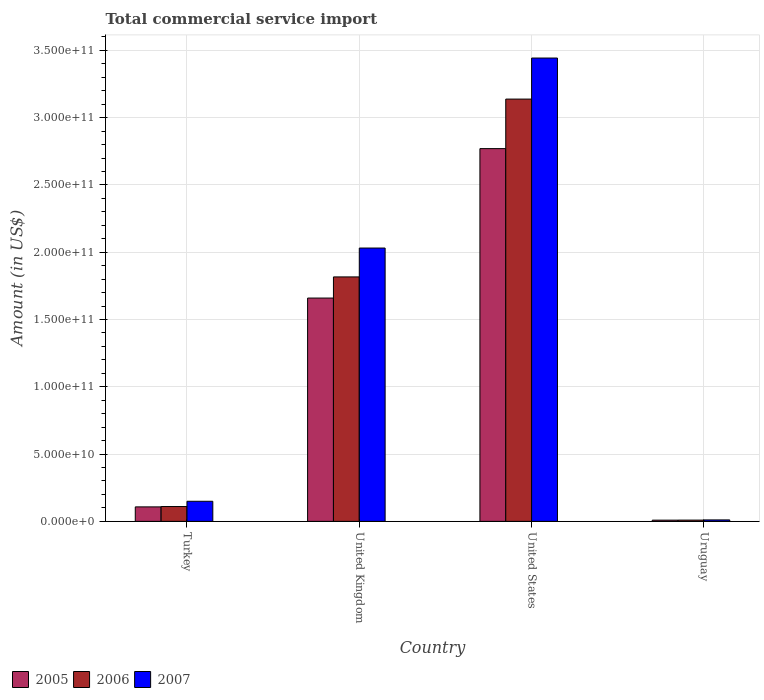How many bars are there on the 1st tick from the left?
Make the answer very short. 3. How many bars are there on the 3rd tick from the right?
Your answer should be compact. 3. What is the total commercial service import in 2006 in United States?
Give a very brief answer. 3.14e+11. Across all countries, what is the maximum total commercial service import in 2006?
Provide a short and direct response. 3.14e+11. Across all countries, what is the minimum total commercial service import in 2006?
Your answer should be compact. 9.37e+08. In which country was the total commercial service import in 2005 minimum?
Offer a terse response. Uruguay. What is the total total commercial service import in 2006 in the graph?
Your answer should be very brief. 5.07e+11. What is the difference between the total commercial service import in 2006 in United States and that in Uruguay?
Your response must be concise. 3.13e+11. What is the difference between the total commercial service import in 2006 in Turkey and the total commercial service import in 2007 in Uruguay?
Give a very brief answer. 9.94e+09. What is the average total commercial service import in 2005 per country?
Ensure brevity in your answer.  1.14e+11. What is the difference between the total commercial service import of/in 2006 and total commercial service import of/in 2005 in United Kingdom?
Keep it short and to the point. 1.57e+1. In how many countries, is the total commercial service import in 2005 greater than 30000000000 US$?
Give a very brief answer. 2. What is the ratio of the total commercial service import in 2006 in United Kingdom to that in United States?
Your response must be concise. 0.58. Is the total commercial service import in 2005 in United Kingdom less than that in United States?
Ensure brevity in your answer.  Yes. Is the difference between the total commercial service import in 2006 in Turkey and United States greater than the difference between the total commercial service import in 2005 in Turkey and United States?
Offer a terse response. No. What is the difference between the highest and the second highest total commercial service import in 2005?
Ensure brevity in your answer.  2.66e+11. What is the difference between the highest and the lowest total commercial service import in 2005?
Offer a very short reply. 2.76e+11. In how many countries, is the total commercial service import in 2007 greater than the average total commercial service import in 2007 taken over all countries?
Provide a short and direct response. 2. What does the 3rd bar from the left in United Kingdom represents?
Provide a succinct answer. 2007. Is it the case that in every country, the sum of the total commercial service import in 2005 and total commercial service import in 2007 is greater than the total commercial service import in 2006?
Your answer should be compact. Yes. How many bars are there?
Offer a terse response. 12. How many countries are there in the graph?
Provide a succinct answer. 4. What is the difference between two consecutive major ticks on the Y-axis?
Your answer should be very brief. 5.00e+1. Are the values on the major ticks of Y-axis written in scientific E-notation?
Your answer should be very brief. Yes. Does the graph contain any zero values?
Your answer should be very brief. No. Does the graph contain grids?
Offer a terse response. Yes. How many legend labels are there?
Keep it short and to the point. 3. What is the title of the graph?
Your response must be concise. Total commercial service import. What is the label or title of the Y-axis?
Ensure brevity in your answer.  Amount (in US$). What is the Amount (in US$) of 2005 in Turkey?
Provide a short and direct response. 1.08e+1. What is the Amount (in US$) in 2006 in Turkey?
Ensure brevity in your answer.  1.10e+1. What is the Amount (in US$) of 2007 in Turkey?
Make the answer very short. 1.49e+1. What is the Amount (in US$) of 2005 in United Kingdom?
Your response must be concise. 1.66e+11. What is the Amount (in US$) of 2006 in United Kingdom?
Provide a succinct answer. 1.82e+11. What is the Amount (in US$) in 2007 in United Kingdom?
Your answer should be compact. 2.03e+11. What is the Amount (in US$) of 2005 in United States?
Give a very brief answer. 2.77e+11. What is the Amount (in US$) of 2006 in United States?
Your response must be concise. 3.14e+11. What is the Amount (in US$) in 2007 in United States?
Your answer should be compact. 3.44e+11. What is the Amount (in US$) in 2005 in Uruguay?
Offer a terse response. 9.01e+08. What is the Amount (in US$) of 2006 in Uruguay?
Ensure brevity in your answer.  9.37e+08. What is the Amount (in US$) in 2007 in Uruguay?
Your answer should be very brief. 1.08e+09. Across all countries, what is the maximum Amount (in US$) in 2005?
Provide a succinct answer. 2.77e+11. Across all countries, what is the maximum Amount (in US$) in 2006?
Offer a terse response. 3.14e+11. Across all countries, what is the maximum Amount (in US$) of 2007?
Keep it short and to the point. 3.44e+11. Across all countries, what is the minimum Amount (in US$) of 2005?
Provide a short and direct response. 9.01e+08. Across all countries, what is the minimum Amount (in US$) of 2006?
Offer a terse response. 9.37e+08. Across all countries, what is the minimum Amount (in US$) of 2007?
Keep it short and to the point. 1.08e+09. What is the total Amount (in US$) in 2005 in the graph?
Give a very brief answer. 4.55e+11. What is the total Amount (in US$) of 2006 in the graph?
Provide a short and direct response. 5.07e+11. What is the total Amount (in US$) of 2007 in the graph?
Provide a succinct answer. 5.63e+11. What is the difference between the Amount (in US$) of 2005 in Turkey and that in United Kingdom?
Ensure brevity in your answer.  -1.55e+11. What is the difference between the Amount (in US$) in 2006 in Turkey and that in United Kingdom?
Offer a terse response. -1.71e+11. What is the difference between the Amount (in US$) of 2007 in Turkey and that in United Kingdom?
Provide a succinct answer. -1.88e+11. What is the difference between the Amount (in US$) of 2005 in Turkey and that in United States?
Make the answer very short. -2.66e+11. What is the difference between the Amount (in US$) of 2006 in Turkey and that in United States?
Provide a short and direct response. -3.03e+11. What is the difference between the Amount (in US$) in 2007 in Turkey and that in United States?
Provide a succinct answer. -3.29e+11. What is the difference between the Amount (in US$) of 2005 in Turkey and that in Uruguay?
Give a very brief answer. 9.86e+09. What is the difference between the Amount (in US$) in 2006 in Turkey and that in Uruguay?
Your answer should be very brief. 1.01e+1. What is the difference between the Amount (in US$) of 2007 in Turkey and that in Uruguay?
Your answer should be compact. 1.39e+1. What is the difference between the Amount (in US$) in 2005 in United Kingdom and that in United States?
Your response must be concise. -1.11e+11. What is the difference between the Amount (in US$) in 2006 in United Kingdom and that in United States?
Give a very brief answer. -1.32e+11. What is the difference between the Amount (in US$) of 2007 in United Kingdom and that in United States?
Your response must be concise. -1.41e+11. What is the difference between the Amount (in US$) in 2005 in United Kingdom and that in Uruguay?
Give a very brief answer. 1.65e+11. What is the difference between the Amount (in US$) of 2006 in United Kingdom and that in Uruguay?
Provide a succinct answer. 1.81e+11. What is the difference between the Amount (in US$) of 2007 in United Kingdom and that in Uruguay?
Provide a succinct answer. 2.02e+11. What is the difference between the Amount (in US$) in 2005 in United States and that in Uruguay?
Your answer should be very brief. 2.76e+11. What is the difference between the Amount (in US$) of 2006 in United States and that in Uruguay?
Offer a terse response. 3.13e+11. What is the difference between the Amount (in US$) of 2007 in United States and that in Uruguay?
Ensure brevity in your answer.  3.43e+11. What is the difference between the Amount (in US$) of 2005 in Turkey and the Amount (in US$) of 2006 in United Kingdom?
Offer a very short reply. -1.71e+11. What is the difference between the Amount (in US$) in 2005 in Turkey and the Amount (in US$) in 2007 in United Kingdom?
Offer a very short reply. -1.92e+11. What is the difference between the Amount (in US$) in 2006 in Turkey and the Amount (in US$) in 2007 in United Kingdom?
Offer a very short reply. -1.92e+11. What is the difference between the Amount (in US$) of 2005 in Turkey and the Amount (in US$) of 2006 in United States?
Your answer should be compact. -3.03e+11. What is the difference between the Amount (in US$) in 2005 in Turkey and the Amount (in US$) in 2007 in United States?
Keep it short and to the point. -3.34e+11. What is the difference between the Amount (in US$) in 2006 in Turkey and the Amount (in US$) in 2007 in United States?
Your answer should be very brief. -3.33e+11. What is the difference between the Amount (in US$) of 2005 in Turkey and the Amount (in US$) of 2006 in Uruguay?
Provide a short and direct response. 9.82e+09. What is the difference between the Amount (in US$) in 2005 in Turkey and the Amount (in US$) in 2007 in Uruguay?
Ensure brevity in your answer.  9.68e+09. What is the difference between the Amount (in US$) of 2006 in Turkey and the Amount (in US$) of 2007 in Uruguay?
Your answer should be compact. 9.94e+09. What is the difference between the Amount (in US$) in 2005 in United Kingdom and the Amount (in US$) in 2006 in United States?
Keep it short and to the point. -1.48e+11. What is the difference between the Amount (in US$) of 2005 in United Kingdom and the Amount (in US$) of 2007 in United States?
Provide a succinct answer. -1.78e+11. What is the difference between the Amount (in US$) in 2006 in United Kingdom and the Amount (in US$) in 2007 in United States?
Provide a short and direct response. -1.63e+11. What is the difference between the Amount (in US$) in 2005 in United Kingdom and the Amount (in US$) in 2006 in Uruguay?
Offer a terse response. 1.65e+11. What is the difference between the Amount (in US$) in 2005 in United Kingdom and the Amount (in US$) in 2007 in Uruguay?
Provide a succinct answer. 1.65e+11. What is the difference between the Amount (in US$) of 2006 in United Kingdom and the Amount (in US$) of 2007 in Uruguay?
Give a very brief answer. 1.81e+11. What is the difference between the Amount (in US$) in 2005 in United States and the Amount (in US$) in 2006 in Uruguay?
Your answer should be very brief. 2.76e+11. What is the difference between the Amount (in US$) of 2005 in United States and the Amount (in US$) of 2007 in Uruguay?
Give a very brief answer. 2.76e+11. What is the difference between the Amount (in US$) in 2006 in United States and the Amount (in US$) in 2007 in Uruguay?
Ensure brevity in your answer.  3.13e+11. What is the average Amount (in US$) in 2005 per country?
Your answer should be compact. 1.14e+11. What is the average Amount (in US$) in 2006 per country?
Your response must be concise. 1.27e+11. What is the average Amount (in US$) in 2007 per country?
Offer a terse response. 1.41e+11. What is the difference between the Amount (in US$) of 2005 and Amount (in US$) of 2006 in Turkey?
Make the answer very short. -2.61e+08. What is the difference between the Amount (in US$) in 2005 and Amount (in US$) in 2007 in Turkey?
Make the answer very short. -4.18e+09. What is the difference between the Amount (in US$) in 2006 and Amount (in US$) in 2007 in Turkey?
Give a very brief answer. -3.92e+09. What is the difference between the Amount (in US$) of 2005 and Amount (in US$) of 2006 in United Kingdom?
Offer a very short reply. -1.57e+1. What is the difference between the Amount (in US$) of 2005 and Amount (in US$) of 2007 in United Kingdom?
Your answer should be compact. -3.72e+1. What is the difference between the Amount (in US$) in 2006 and Amount (in US$) in 2007 in United Kingdom?
Give a very brief answer. -2.15e+1. What is the difference between the Amount (in US$) in 2005 and Amount (in US$) in 2006 in United States?
Provide a succinct answer. -3.68e+1. What is the difference between the Amount (in US$) in 2005 and Amount (in US$) in 2007 in United States?
Offer a very short reply. -6.73e+1. What is the difference between the Amount (in US$) of 2006 and Amount (in US$) of 2007 in United States?
Your answer should be very brief. -3.05e+1. What is the difference between the Amount (in US$) in 2005 and Amount (in US$) in 2006 in Uruguay?
Provide a succinct answer. -3.66e+07. What is the difference between the Amount (in US$) in 2005 and Amount (in US$) in 2007 in Uruguay?
Your answer should be very brief. -1.78e+08. What is the difference between the Amount (in US$) of 2006 and Amount (in US$) of 2007 in Uruguay?
Your response must be concise. -1.41e+08. What is the ratio of the Amount (in US$) in 2005 in Turkey to that in United Kingdom?
Your answer should be very brief. 0.06. What is the ratio of the Amount (in US$) of 2006 in Turkey to that in United Kingdom?
Offer a terse response. 0.06. What is the ratio of the Amount (in US$) of 2007 in Turkey to that in United Kingdom?
Keep it short and to the point. 0.07. What is the ratio of the Amount (in US$) in 2005 in Turkey to that in United States?
Give a very brief answer. 0.04. What is the ratio of the Amount (in US$) in 2006 in Turkey to that in United States?
Offer a terse response. 0.04. What is the ratio of the Amount (in US$) of 2007 in Turkey to that in United States?
Ensure brevity in your answer.  0.04. What is the ratio of the Amount (in US$) of 2005 in Turkey to that in Uruguay?
Your answer should be very brief. 11.94. What is the ratio of the Amount (in US$) of 2006 in Turkey to that in Uruguay?
Your answer should be very brief. 11.75. What is the ratio of the Amount (in US$) of 2007 in Turkey to that in Uruguay?
Provide a short and direct response. 13.84. What is the ratio of the Amount (in US$) of 2005 in United Kingdom to that in United States?
Offer a very short reply. 0.6. What is the ratio of the Amount (in US$) in 2006 in United Kingdom to that in United States?
Your answer should be compact. 0.58. What is the ratio of the Amount (in US$) of 2007 in United Kingdom to that in United States?
Keep it short and to the point. 0.59. What is the ratio of the Amount (in US$) of 2005 in United Kingdom to that in Uruguay?
Your answer should be compact. 184.23. What is the ratio of the Amount (in US$) in 2006 in United Kingdom to that in Uruguay?
Keep it short and to the point. 193.8. What is the ratio of the Amount (in US$) of 2007 in United Kingdom to that in Uruguay?
Your answer should be very brief. 188.3. What is the ratio of the Amount (in US$) in 2005 in United States to that in Uruguay?
Give a very brief answer. 307.51. What is the ratio of the Amount (in US$) in 2006 in United States to that in Uruguay?
Your response must be concise. 334.79. What is the ratio of the Amount (in US$) of 2007 in United States to that in Uruguay?
Your answer should be very brief. 319.19. What is the difference between the highest and the second highest Amount (in US$) in 2005?
Provide a short and direct response. 1.11e+11. What is the difference between the highest and the second highest Amount (in US$) of 2006?
Your answer should be very brief. 1.32e+11. What is the difference between the highest and the second highest Amount (in US$) in 2007?
Your response must be concise. 1.41e+11. What is the difference between the highest and the lowest Amount (in US$) of 2005?
Your answer should be compact. 2.76e+11. What is the difference between the highest and the lowest Amount (in US$) in 2006?
Offer a very short reply. 3.13e+11. What is the difference between the highest and the lowest Amount (in US$) of 2007?
Keep it short and to the point. 3.43e+11. 